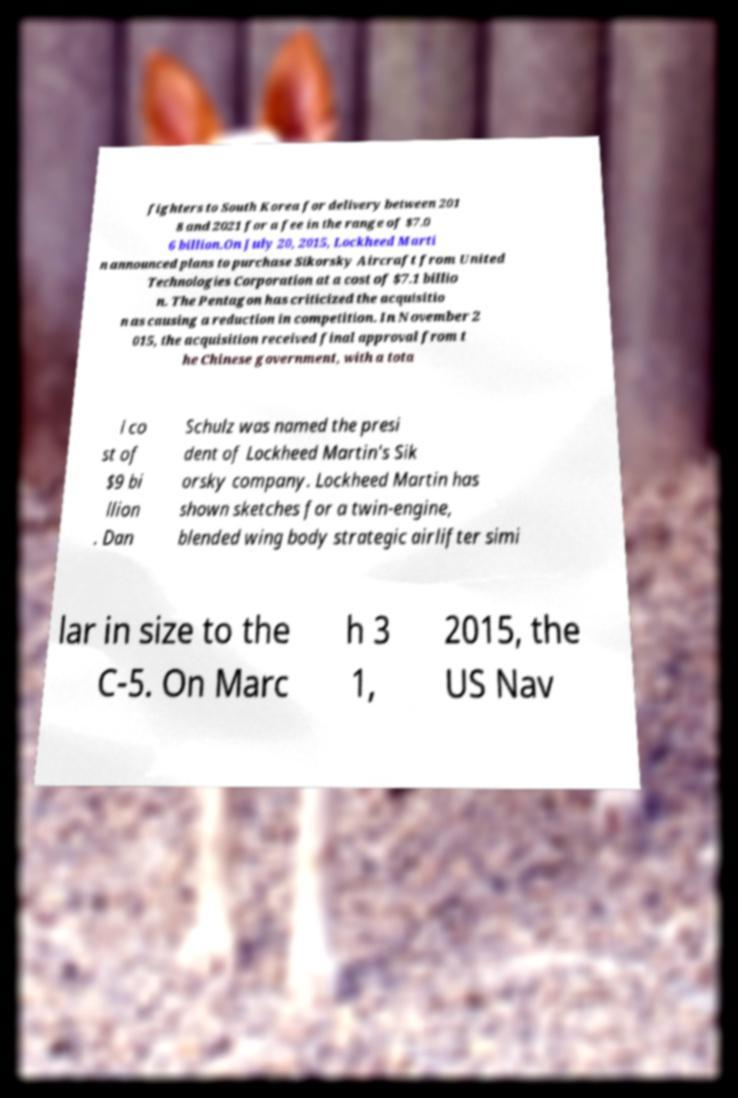I need the written content from this picture converted into text. Can you do that? fighters to South Korea for delivery between 201 8 and 2021 for a fee in the range of $7.0 6 billion.On July 20, 2015, Lockheed Marti n announced plans to purchase Sikorsky Aircraft from United Technologies Corporation at a cost of $7.1 billio n. The Pentagon has criticized the acquisitio n as causing a reduction in competition. In November 2 015, the acquisition received final approval from t he Chinese government, with a tota l co st of $9 bi llion . Dan Schulz was named the presi dent of Lockheed Martin's Sik orsky company. Lockheed Martin has shown sketches for a twin-engine, blended wing body strategic airlifter simi lar in size to the C-5. On Marc h 3 1, 2015, the US Nav 